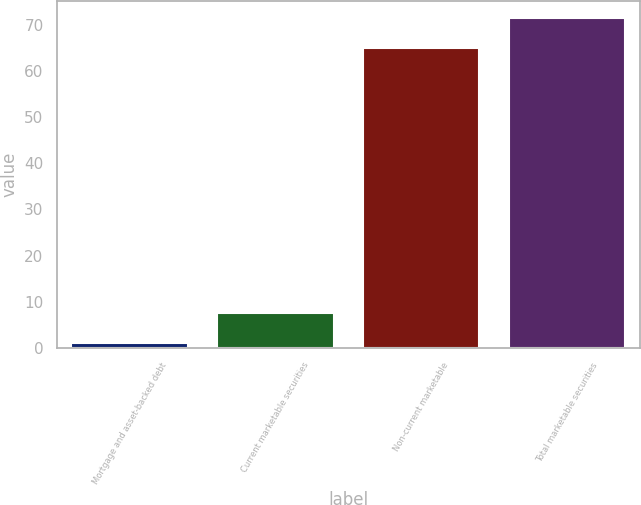<chart> <loc_0><loc_0><loc_500><loc_500><bar_chart><fcel>Mortgage and asset-backed debt<fcel>Current marketable securities<fcel>Non-current marketable<fcel>Total marketable securities<nl><fcel>1<fcel>7.6<fcel>65<fcel>71.6<nl></chart> 